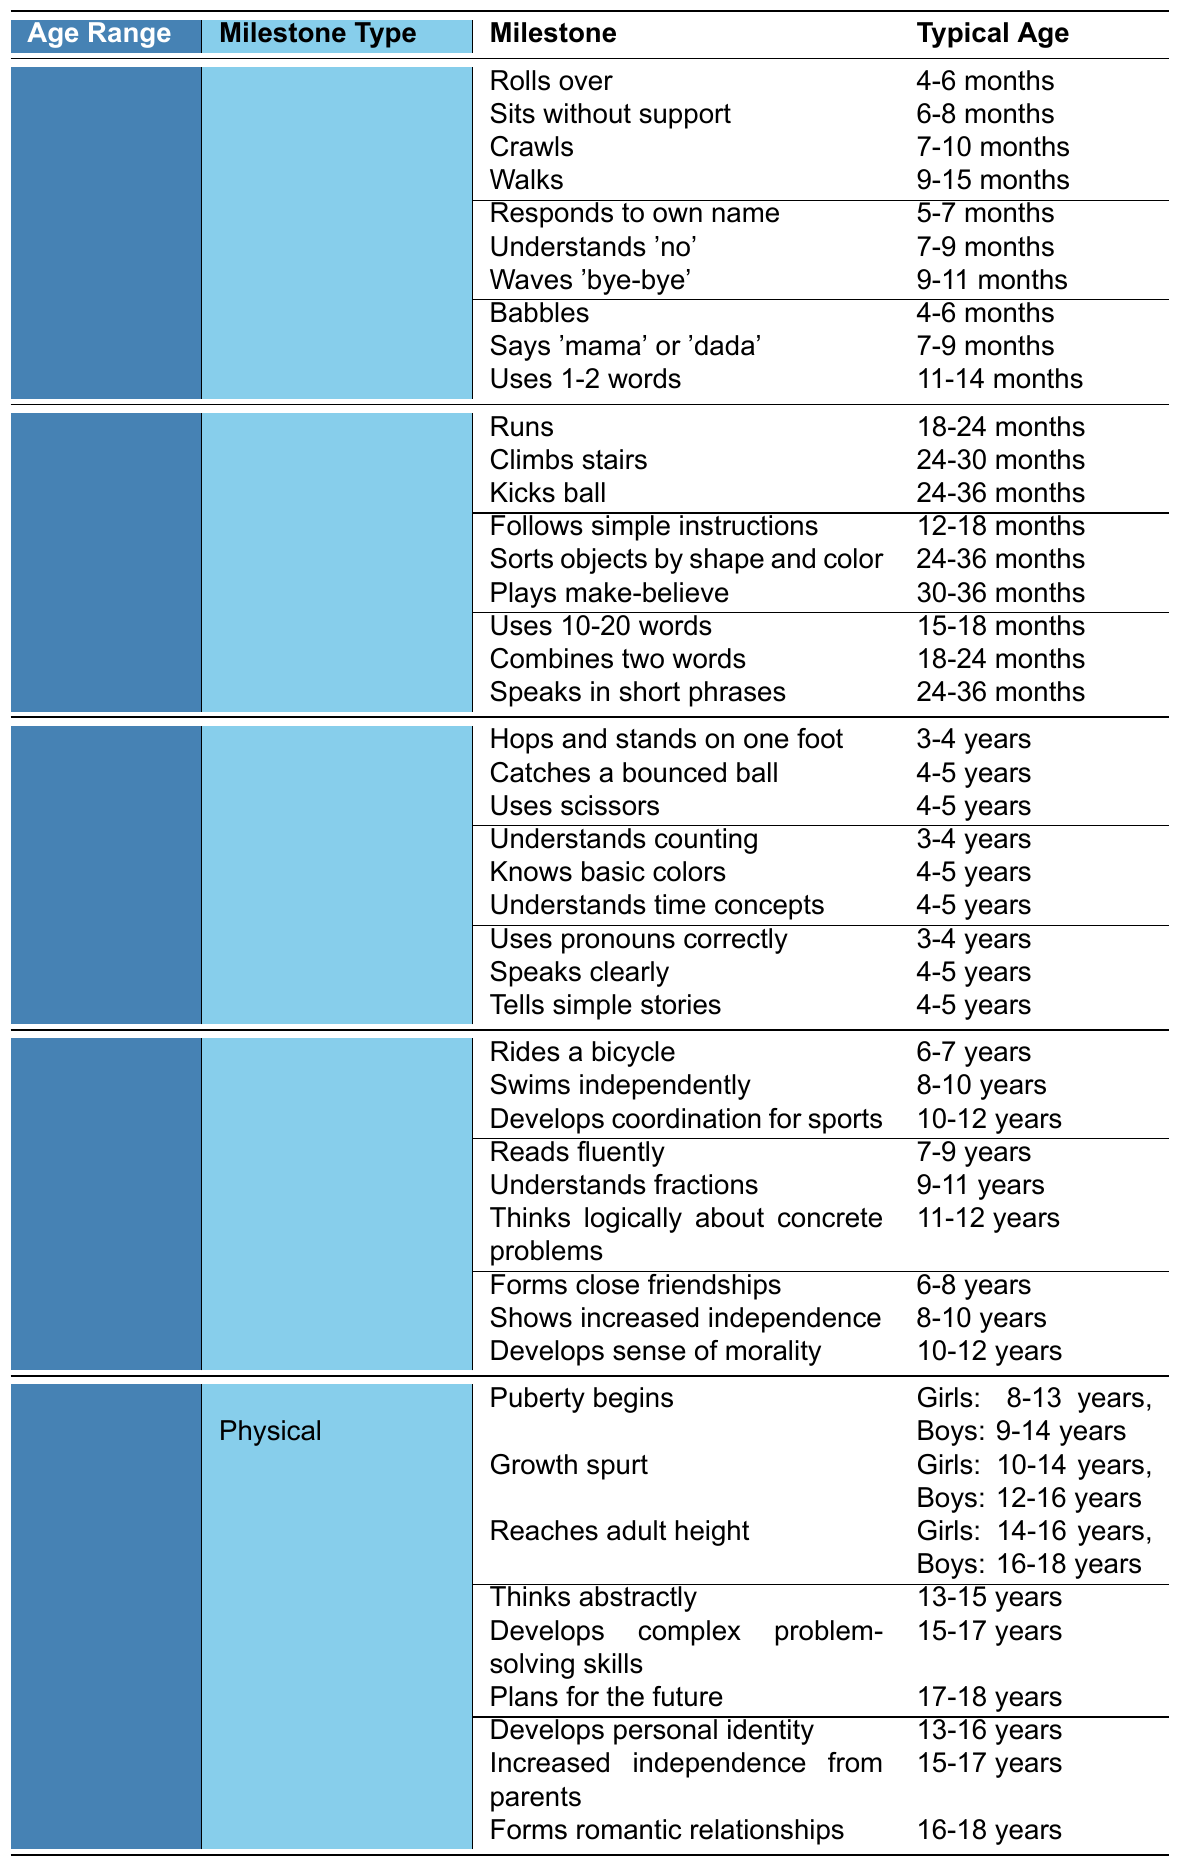What is the typical age for a child to walk? The milestone of walking occurs typically between 9-15 months; this information is found in the 'Physical Milestones' section for the age range of 0-12 months.
Answer: 9-15 months At what age does a child typically start to kick a ball? According to the 'Physical Milestones' for the age range of 1-3 years, the typical age for kicking a ball is between 24-36 months.
Answer: 24-36 months Does a 2-year-old usually combine two words? Yes, the 'Language Milestones' for children aged 1-3 years indicates that children typically combine two words between 18-24 months.
Answer: Yes What physical milestone is expected for a 4-year-old? The table shows that a 4-year-old is expected to hop and stand on one foot, as indicated in the 'Physical Milestones' section for the age range of 3-5 years.
Answer: Hops and stands on one foot How many cognitive milestones are listed for children aged 6-12 years? There are 9 cognitive milestones listed in the 'Cognitive Milestones' section for children aged 6-12 years, as each age range has 3 milestones.
Answer: 9 Which age group includes the milestone of developing a sense of morality? The milestone of developing a sense of morality is included in the 'Social-Emotional Milestones' section for the age range of 10-12 years within the 6-12 years category.
Answer: 6-12 years At what age range do children start puberty? Based on the information provided, puberty typically begins for girls between 8-13 years and for boys between 9-14 years, in the 'Physical Milestones' for the age range of 13-18 years.
Answer: Girls: 8-13 years, Boys: 9-14 years What cognitive milestone develops last in children aged 13-18 years? The last cognitive milestone listed in the table for children aged 13-18 years is "Plans for the future," which typically occurs between 17-18 years.
Answer: 17-18 years Is it true that a child learns to ride a bicycle by age 5? No, the table shows that the milestone of riding a bicycle typically occurs between 6-7 years of age, not by age 5.
Answer: No What is the difference in typical age range between a child learning to swim independently and one who reads fluently? A child typically learns to swim independently between 8-10 years, while they learn to read fluently between 7-9 years. The difference in the starting age is 1 year.
Answer: 1 year difference 